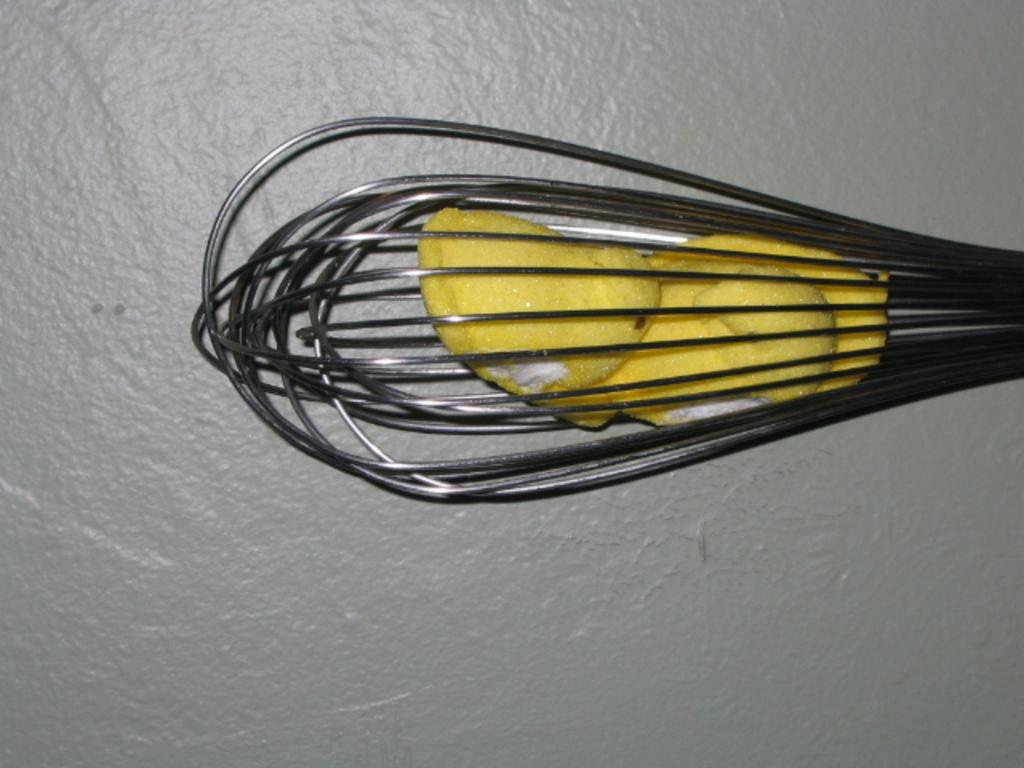What can be seen in the image that is used for eating or cooking? There is a utensil in the image that can be used for eating or cooking. What is placed on the surface of the utensil? There is an object placed on the surface of the utensil. Where is the library located in the image? There is no library present in the image. How many chickens can be seen in the image? There are no chickens present in the image. 